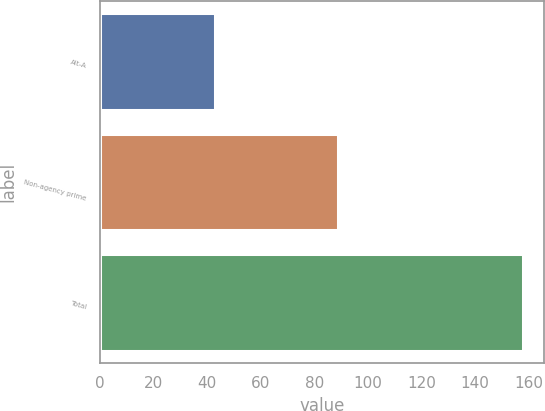<chart> <loc_0><loc_0><loc_500><loc_500><bar_chart><fcel>Alt-A<fcel>Non-agency prime<fcel>Total<nl><fcel>43<fcel>89<fcel>158<nl></chart> 